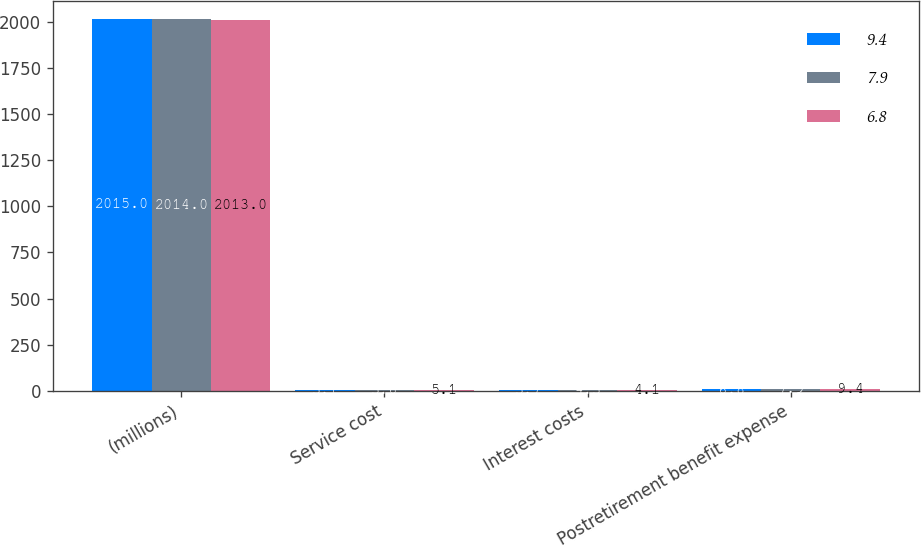Convert chart to OTSL. <chart><loc_0><loc_0><loc_500><loc_500><stacked_bar_chart><ecel><fcel>(millions)<fcel>Service cost<fcel>Interest costs<fcel>Postretirement benefit expense<nl><fcel>9.4<fcel>2015<fcel>3.1<fcel>3.7<fcel>6.8<nl><fcel>7.9<fcel>2014<fcel>3.6<fcel>4.3<fcel>7.9<nl><fcel>6.8<fcel>2013<fcel>5.1<fcel>4.1<fcel>9.4<nl></chart> 